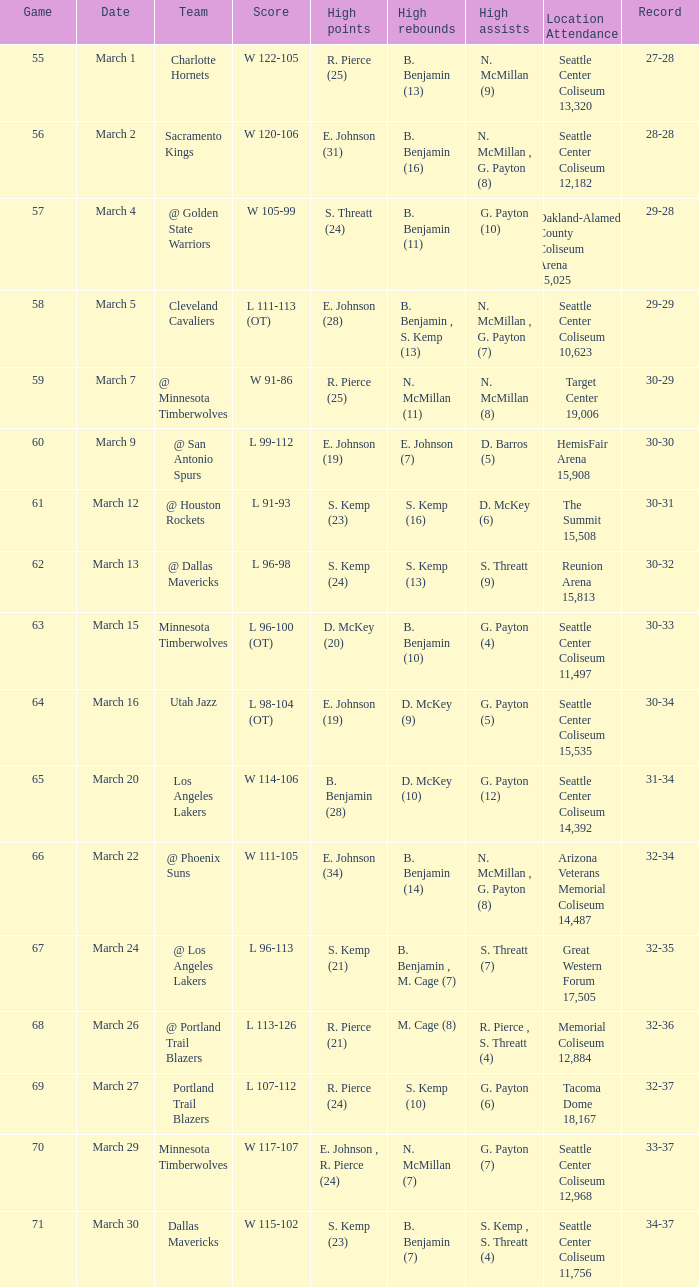What game features a team known as the portland trail blazers? 69.0. 